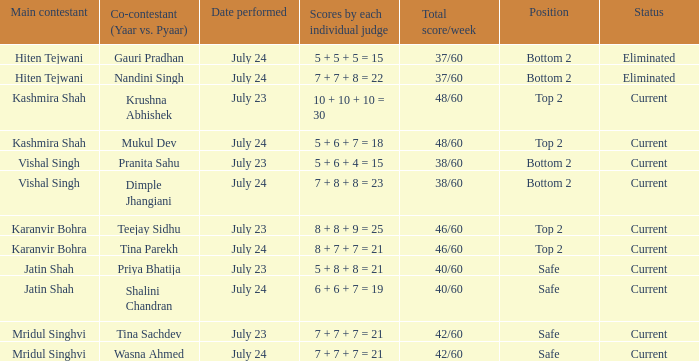Who is the co-contestant (yaar vs. Pyaar) with Vishal Singh as the main contestant? Pranita Sahu, Dimple Jhangiani. 